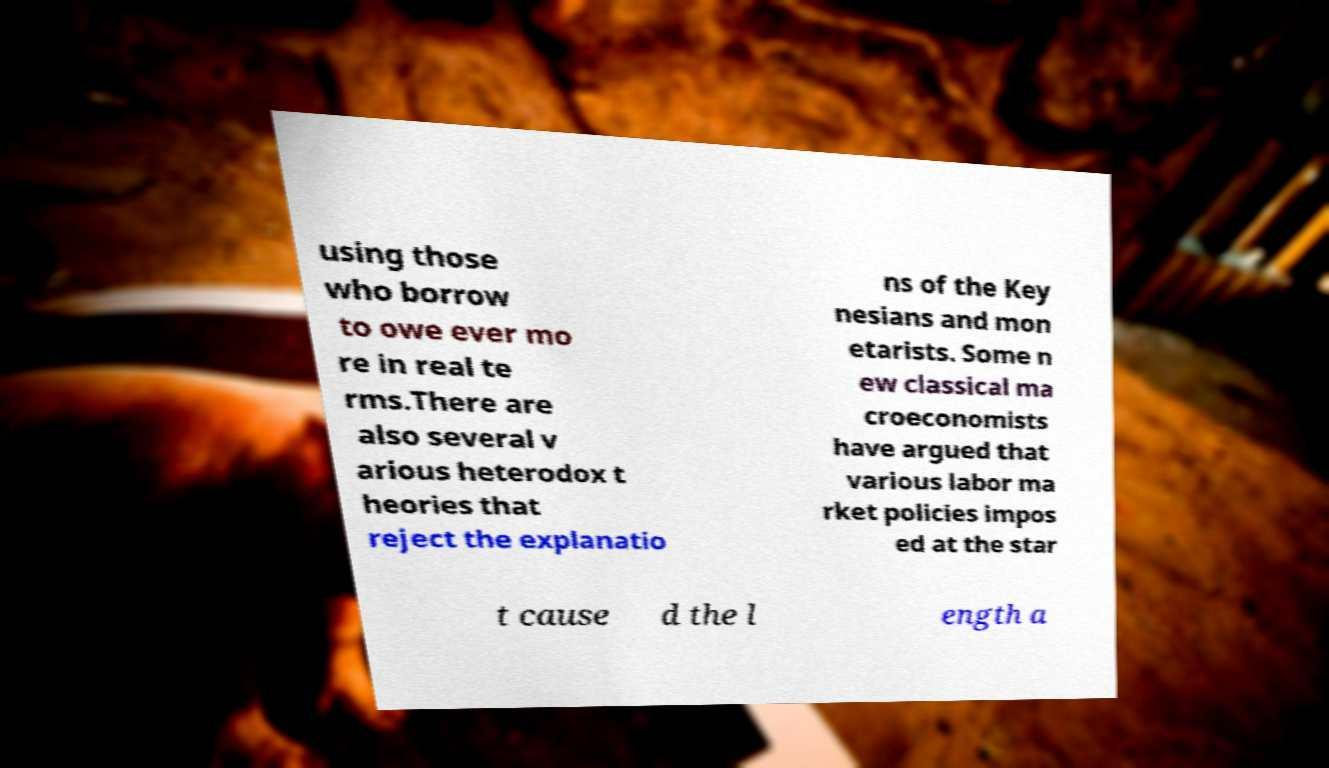Can you read and provide the text displayed in the image?This photo seems to have some interesting text. Can you extract and type it out for me? using those who borrow to owe ever mo re in real te rms.There are also several v arious heterodox t heories that reject the explanatio ns of the Key nesians and mon etarists. Some n ew classical ma croeconomists have argued that various labor ma rket policies impos ed at the star t cause d the l ength a 